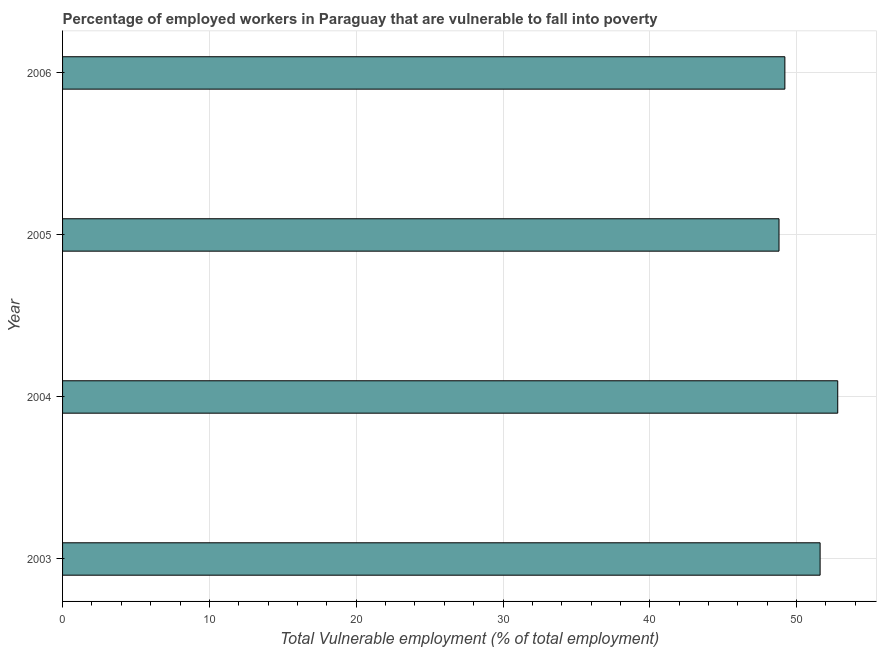Does the graph contain any zero values?
Make the answer very short. No. What is the title of the graph?
Your answer should be compact. Percentage of employed workers in Paraguay that are vulnerable to fall into poverty. What is the label or title of the X-axis?
Provide a short and direct response. Total Vulnerable employment (% of total employment). What is the label or title of the Y-axis?
Offer a very short reply. Year. What is the total vulnerable employment in 2006?
Make the answer very short. 49.2. Across all years, what is the maximum total vulnerable employment?
Offer a terse response. 52.8. Across all years, what is the minimum total vulnerable employment?
Your answer should be compact. 48.8. In which year was the total vulnerable employment maximum?
Your response must be concise. 2004. What is the sum of the total vulnerable employment?
Your answer should be compact. 202.4. What is the difference between the total vulnerable employment in 2003 and 2004?
Your response must be concise. -1.2. What is the average total vulnerable employment per year?
Ensure brevity in your answer.  50.6. What is the median total vulnerable employment?
Your answer should be very brief. 50.4. In how many years, is the total vulnerable employment greater than 26 %?
Your answer should be compact. 4. Do a majority of the years between 2004 and 2005 (inclusive) have total vulnerable employment greater than 24 %?
Your response must be concise. Yes. What is the ratio of the total vulnerable employment in 2003 to that in 2006?
Keep it short and to the point. 1.05. Is the total vulnerable employment in 2004 less than that in 2006?
Your answer should be very brief. No. Is the difference between the total vulnerable employment in 2004 and 2005 greater than the difference between any two years?
Your answer should be compact. Yes. Is the sum of the total vulnerable employment in 2004 and 2006 greater than the maximum total vulnerable employment across all years?
Your answer should be very brief. Yes. In how many years, is the total vulnerable employment greater than the average total vulnerable employment taken over all years?
Give a very brief answer. 2. Are all the bars in the graph horizontal?
Ensure brevity in your answer.  Yes. Are the values on the major ticks of X-axis written in scientific E-notation?
Offer a very short reply. No. What is the Total Vulnerable employment (% of total employment) of 2003?
Make the answer very short. 51.6. What is the Total Vulnerable employment (% of total employment) in 2004?
Give a very brief answer. 52.8. What is the Total Vulnerable employment (% of total employment) in 2005?
Your answer should be compact. 48.8. What is the Total Vulnerable employment (% of total employment) of 2006?
Ensure brevity in your answer.  49.2. What is the difference between the Total Vulnerable employment (% of total employment) in 2003 and 2004?
Your answer should be very brief. -1.2. What is the difference between the Total Vulnerable employment (% of total employment) in 2003 and 2005?
Offer a terse response. 2.8. What is the difference between the Total Vulnerable employment (% of total employment) in 2004 and 2005?
Keep it short and to the point. 4. What is the ratio of the Total Vulnerable employment (% of total employment) in 2003 to that in 2004?
Provide a succinct answer. 0.98. What is the ratio of the Total Vulnerable employment (% of total employment) in 2003 to that in 2005?
Provide a succinct answer. 1.06. What is the ratio of the Total Vulnerable employment (% of total employment) in 2003 to that in 2006?
Your answer should be compact. 1.05. What is the ratio of the Total Vulnerable employment (% of total employment) in 2004 to that in 2005?
Offer a terse response. 1.08. What is the ratio of the Total Vulnerable employment (% of total employment) in 2004 to that in 2006?
Offer a very short reply. 1.07. What is the ratio of the Total Vulnerable employment (% of total employment) in 2005 to that in 2006?
Your response must be concise. 0.99. 